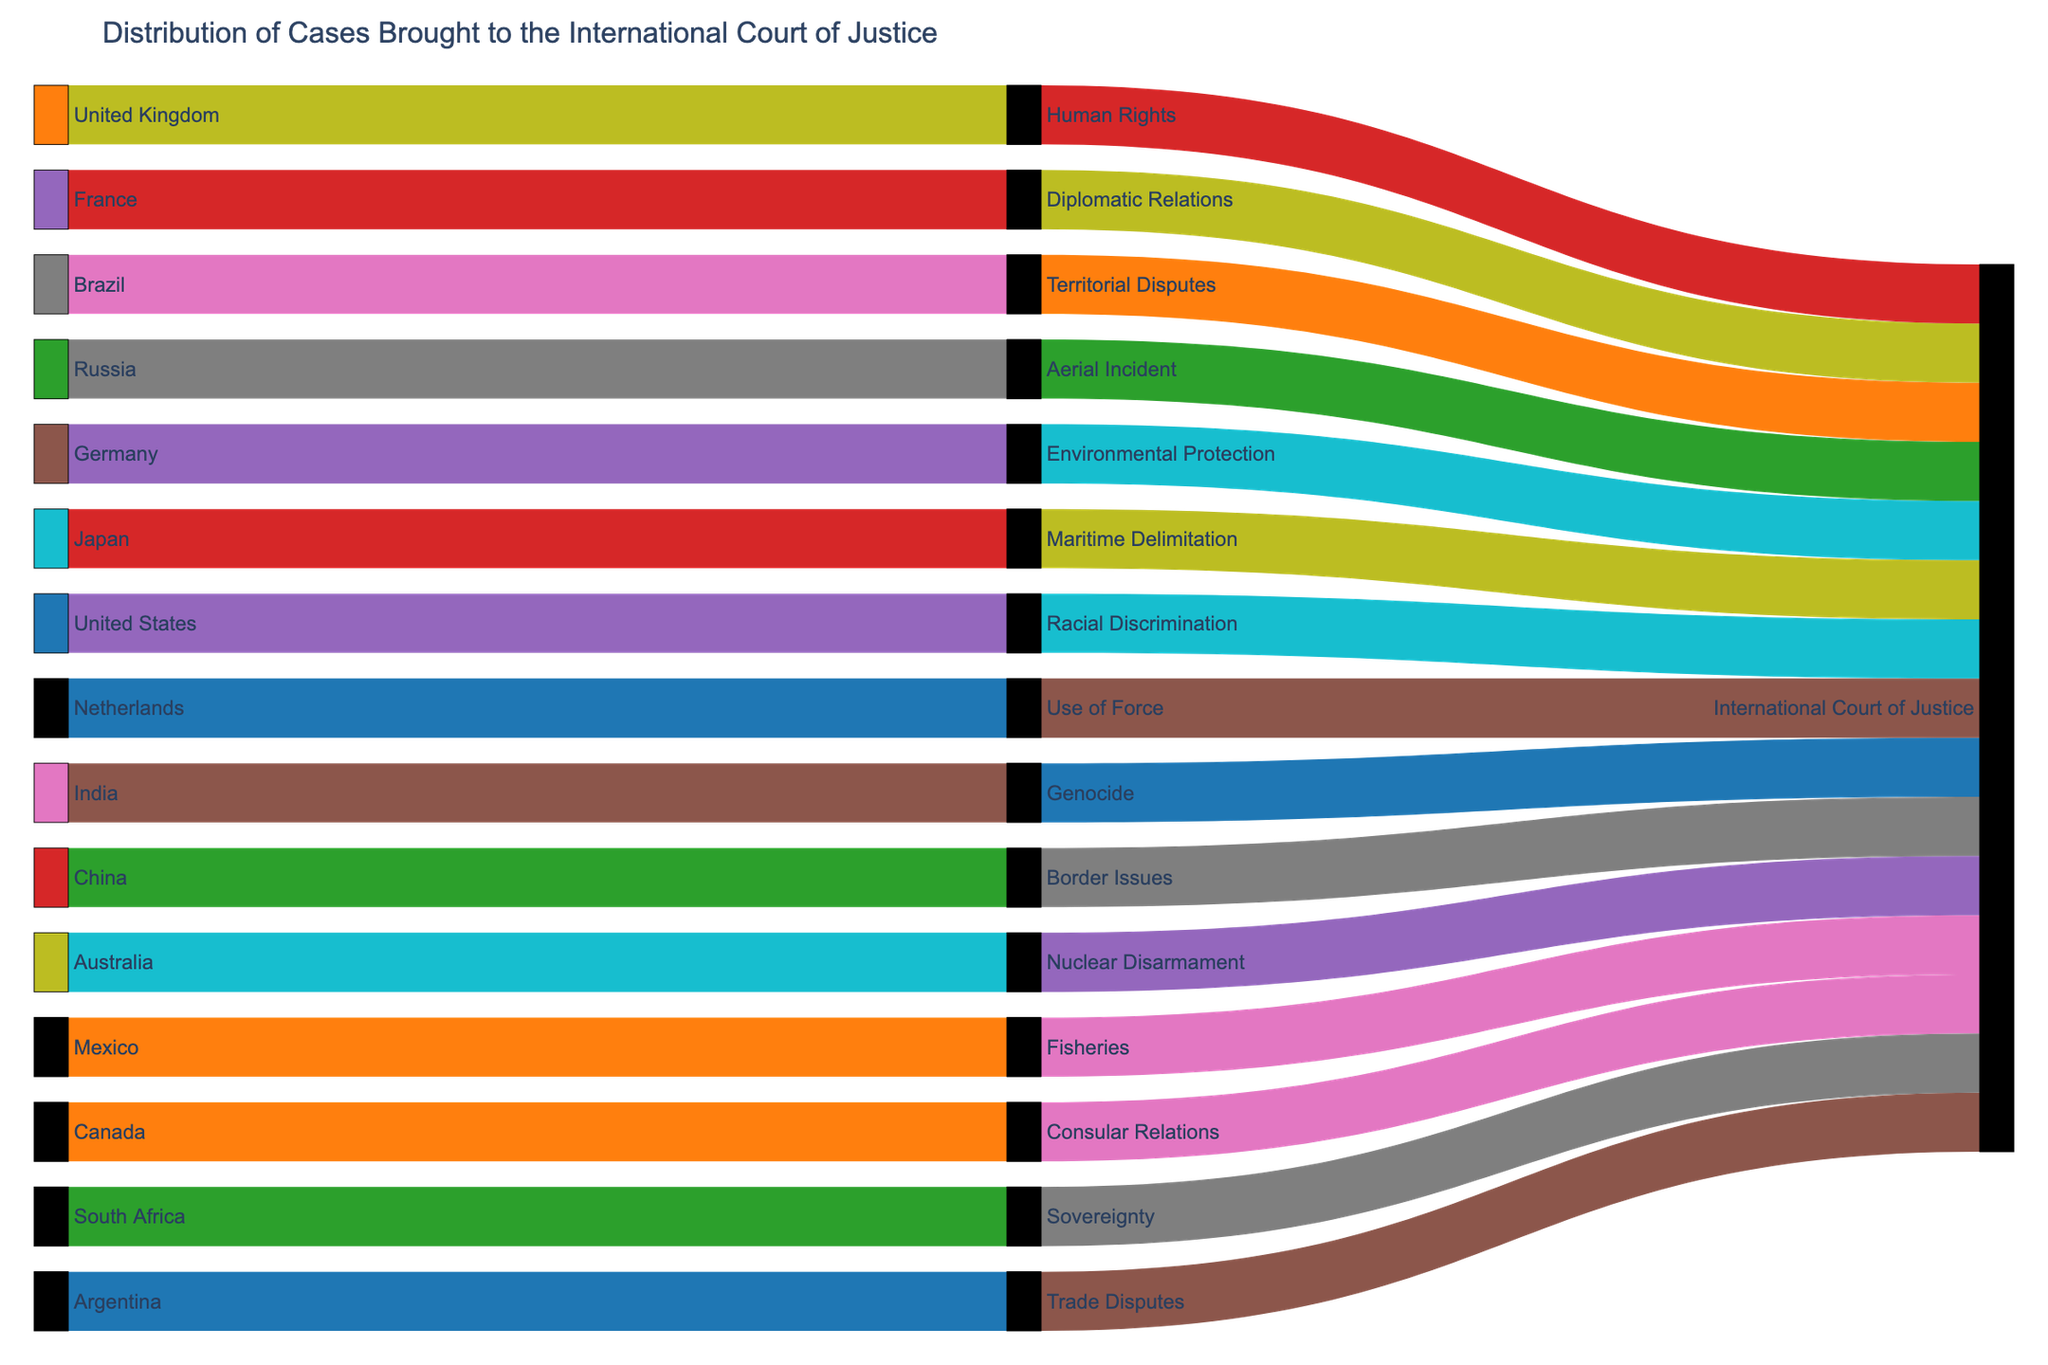What is the title of the Sankey diagram? The title is typically found at the top of the diagram and provides a summary of what the figure is about.
Answer: Distribution of Cases Brought to the International Court of Justice How many subject matters are represented in the diagram? The subject matters can be counted by looking at the nodes labeled with different subject topics. Each unique label under 'Subject Matter' represents a different subject.
Answer: 15 Which country brought a case related to Environmental Protection? To answer this, find the 'Environmental Protection' node and trace back to the corresponding country node.
Answer: France What is the color of the 'Human Rights' node? The node color can be identified by visually inspecting the node labeled 'Human Rights' and noting its color.
Answer: Purple Which subject matter has a case brought by Germany? Locate the 'Germany' node and follow the link to the associated 'Subject Matter' node.
Answer: Human Rights How many countries brought cases related to Use of Force and Genocide combined? Count the individual links to the 'Use of Force' and 'Genocide' nodes and sum them up.
Answer: 2 Which subject matter has the highest number of countries bringing cases to the International Court of Justice? Identify the subject with the most incoming links from different countries.
Answer: All subject matters have 1 country each Are there more cases related to Territorial Disputes or Maritime Delimitation? Compare the number of links from countries to the nodes labeled 'Territorial Disputes' and 'Maritime Delimitation'.
Answer: Equal (Both have 1 case) Which two countries brought cases related to consular relations and racial discrimination? Identify and read the labels of the countries connected to 'Consular Relations' and 'Racial Discrimination' nodes. Sum the two.
Answer: Netherlands (Consular Relations) and South Africa (Racial Discrimination) What is the most common theme among the cases brought by different countries? Look at the variety of subject matter nodes and observe any recurring themes in the subjects.
Answer: All subject matters are unique (No single common theme) 